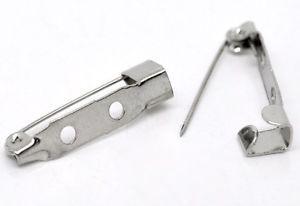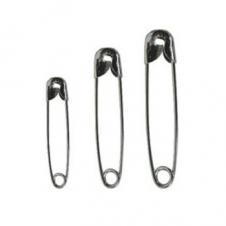The first image is the image on the left, the second image is the image on the right. Considering the images on both sides, is "In one image, no less than three safety pins are arranged in order next to each other by size" valid? Answer yes or no. Yes. The first image is the image on the left, the second image is the image on the right. Given the left and right images, does the statement "An image shows exactly two safety pins, displayed with their clasp ends at the bottom and designed with no loop ends." hold true? Answer yes or no. No. 